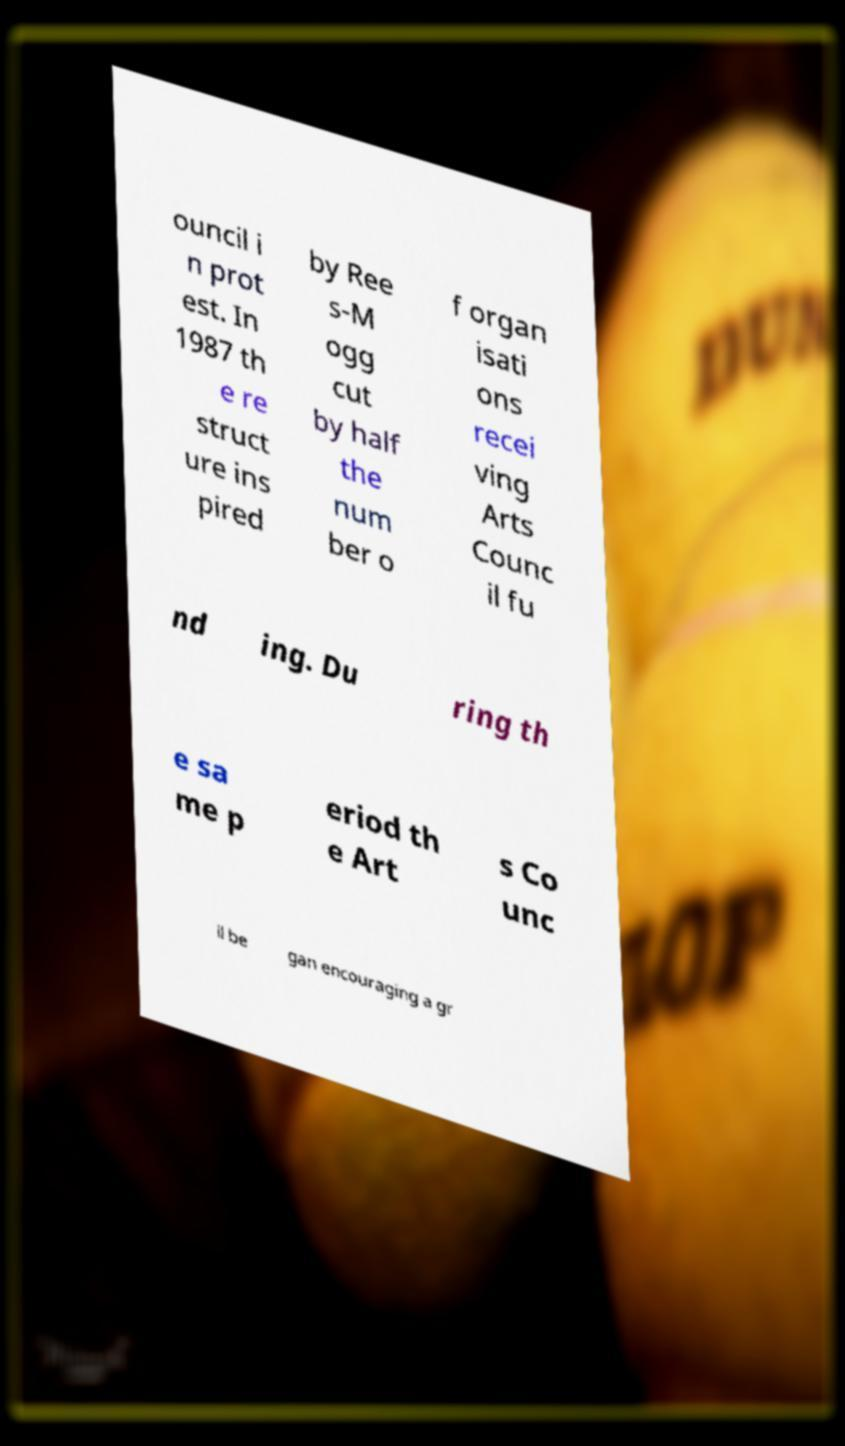What messages or text are displayed in this image? I need them in a readable, typed format. ouncil i n prot est. In 1987 th e re struct ure ins pired by Ree s-M ogg cut by half the num ber o f organ isati ons recei ving Arts Counc il fu nd ing. Du ring th e sa me p eriod th e Art s Co unc il be gan encouraging a gr 